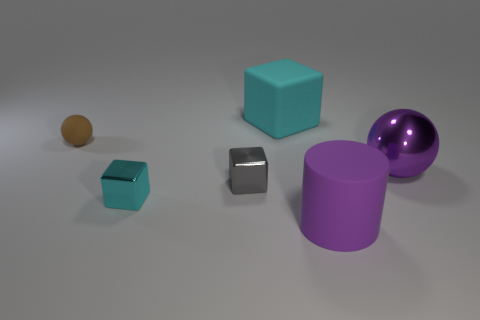There is a cyan thing to the left of the gray shiny cube; does it have the same shape as the gray shiny object?
Ensure brevity in your answer.  Yes. There is a block behind the metallic thing that is to the right of the cyan block behind the tiny cyan object; what is its color?
Provide a succinct answer. Cyan. Are any large purple shiny things visible?
Give a very brief answer. Yes. What number of other things are there of the same size as the cyan rubber cube?
Offer a very short reply. 2. Does the cylinder have the same color as the cube behind the tiny sphere?
Keep it short and to the point. No. What number of objects are either big purple matte objects or tiny gray cylinders?
Your answer should be compact. 1. Is there anything else of the same color as the big shiny sphere?
Give a very brief answer. Yes. Does the large purple sphere have the same material as the cyan cube in front of the metal ball?
Make the answer very short. Yes. What is the shape of the purple object in front of the ball to the right of the large purple rubber cylinder?
Offer a very short reply. Cylinder. There is a rubber thing that is both in front of the big cyan block and to the left of the big rubber cylinder; what shape is it?
Give a very brief answer. Sphere. 